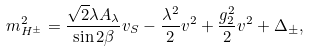<formula> <loc_0><loc_0><loc_500><loc_500>m _ { H ^ { \pm } } ^ { 2 } = \frac { \sqrt { 2 } \lambda A _ { \lambda } } { \sin 2 \beta } v _ { S } - \frac { \lambda ^ { 2 } } { 2 } v ^ { 2 } + \frac { g _ { 2 } ^ { 2 } } { 2 } v ^ { 2 } + \Delta _ { \pm } ,</formula> 